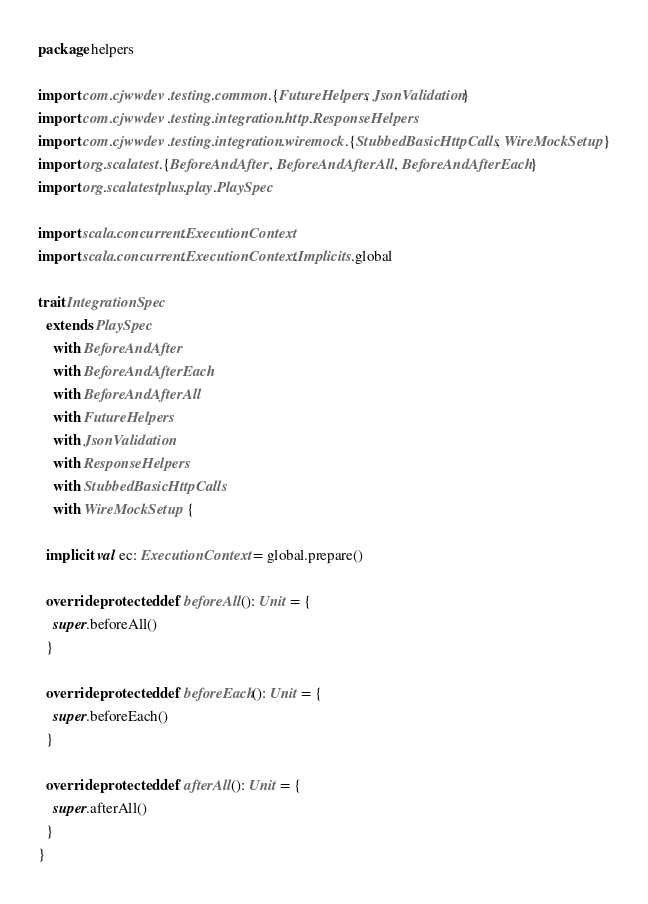<code> <loc_0><loc_0><loc_500><loc_500><_Scala_>
package helpers

import com.cjwwdev.testing.common.{FutureHelpers, JsonValidation}
import com.cjwwdev.testing.integration.http.ResponseHelpers
import com.cjwwdev.testing.integration.wiremock.{StubbedBasicHttpCalls, WireMockSetup}
import org.scalatest.{BeforeAndAfter, BeforeAndAfterAll, BeforeAndAfterEach}
import org.scalatestplus.play.PlaySpec

import scala.concurrent.ExecutionContext
import scala.concurrent.ExecutionContext.Implicits.global

trait IntegrationSpec
  extends PlaySpec
    with BeforeAndAfter
    with BeforeAndAfterEach
    with BeforeAndAfterAll
    with FutureHelpers
    with JsonValidation
    with ResponseHelpers
    with StubbedBasicHttpCalls
    with WireMockSetup {

  implicit val ec: ExecutionContext = global.prepare()

  override protected def beforeAll(): Unit = {
    super.beforeAll()
  }

  override protected def beforeEach(): Unit = {
    super.beforeEach()
  }

  override protected def afterAll(): Unit = {
    super.afterAll()
  }
}
</code> 